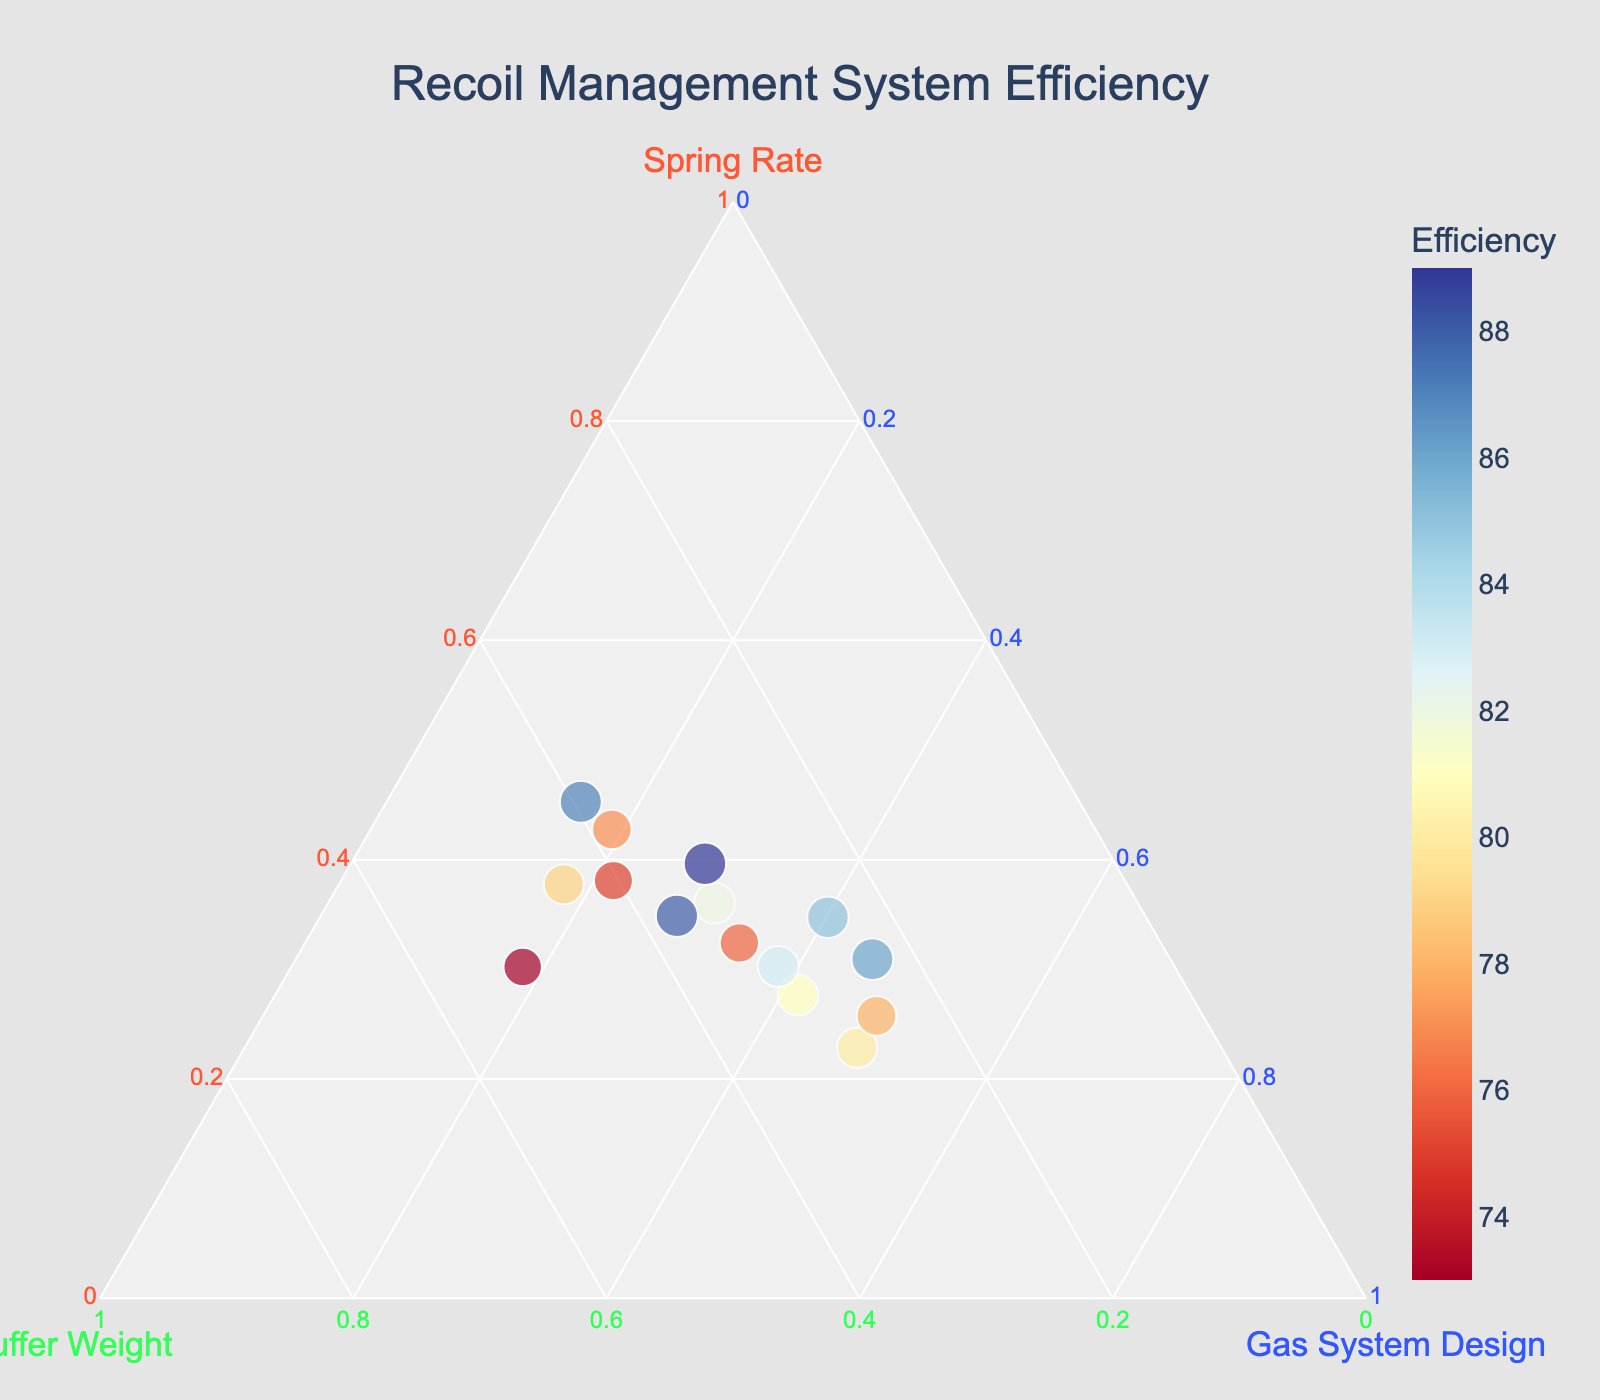What is the title of the plot? The title of the plot is usually displayed at the top of the figure and often describes the main topic or findings being visualized.
Answer: Recoil Management System Efficiency Which axis represents the Spring Rate? In a ternary plot, there are three axes, and each corresponds to a different component. According to the legend, the Spring Rate axis is typically color-coded and labeled.
Answer: The left axis What is the range of Efficiency values displayed? Efficiency varies in color and size in the ternary plot. By looking at the color legend and observing the color gradient, we can see the range of values represented.
Answer: 73 to 89 How does the Gas System Design impact the Efficiency when Spring Rate is around 20? First, identify the data points where the Spring Rate is near 20. Then, observe the efficiency values and the corresponding Gas System Designs. This requires analyzing these points within multiple coordinates.
Answer: Piston-Driven (88), Short-Stroke Piston (83) Which Gas System Design is associated with the highest Efficiency? Locate the data point with the highest efficiency value, then observe its corresponding Gas System Design.
Answer: Piston-Driven Identify the trend in Efficiency for increasing Spring Rate. Examine the trend of data points from lower to higher Spring Rate and observe how the Efficiency values change, typically marked by color or size.
Answer: Efficiency generally increases What Gas System Design has the most balanced configuration? Find the data point closest to the center of the ternary plot, as a balance would be equally contributing values of Spring Rate, Buffer Weight, and Gas System Design.
Answer: Long-Stroke Piston Compare the Efficiency of Direct Impingement systems with Piston-Driven systems. Identify all the data points for Direct Impingement and Piston-Driven systems, take note of their efficiency values, and compare the averages.
Answer: Piston-Driven systems generally have higher Efficiency What is the typical Buffer Weight value when the Efficiency exceeds 80? Identify all data points where Efficiency is higher than 80. Observe and list the corresponding Buffer Weight values, then find the typical or average value.
Answer: Around 3.7 How does the Efficiency vary with Buffer Weight between 3 and 4? Focus on the segment of the plot where the Buffer Weight is between 3 and 4, and observe how the Efficiency values change within this range.
Answer: Efficiency ranges from 75 to 85 